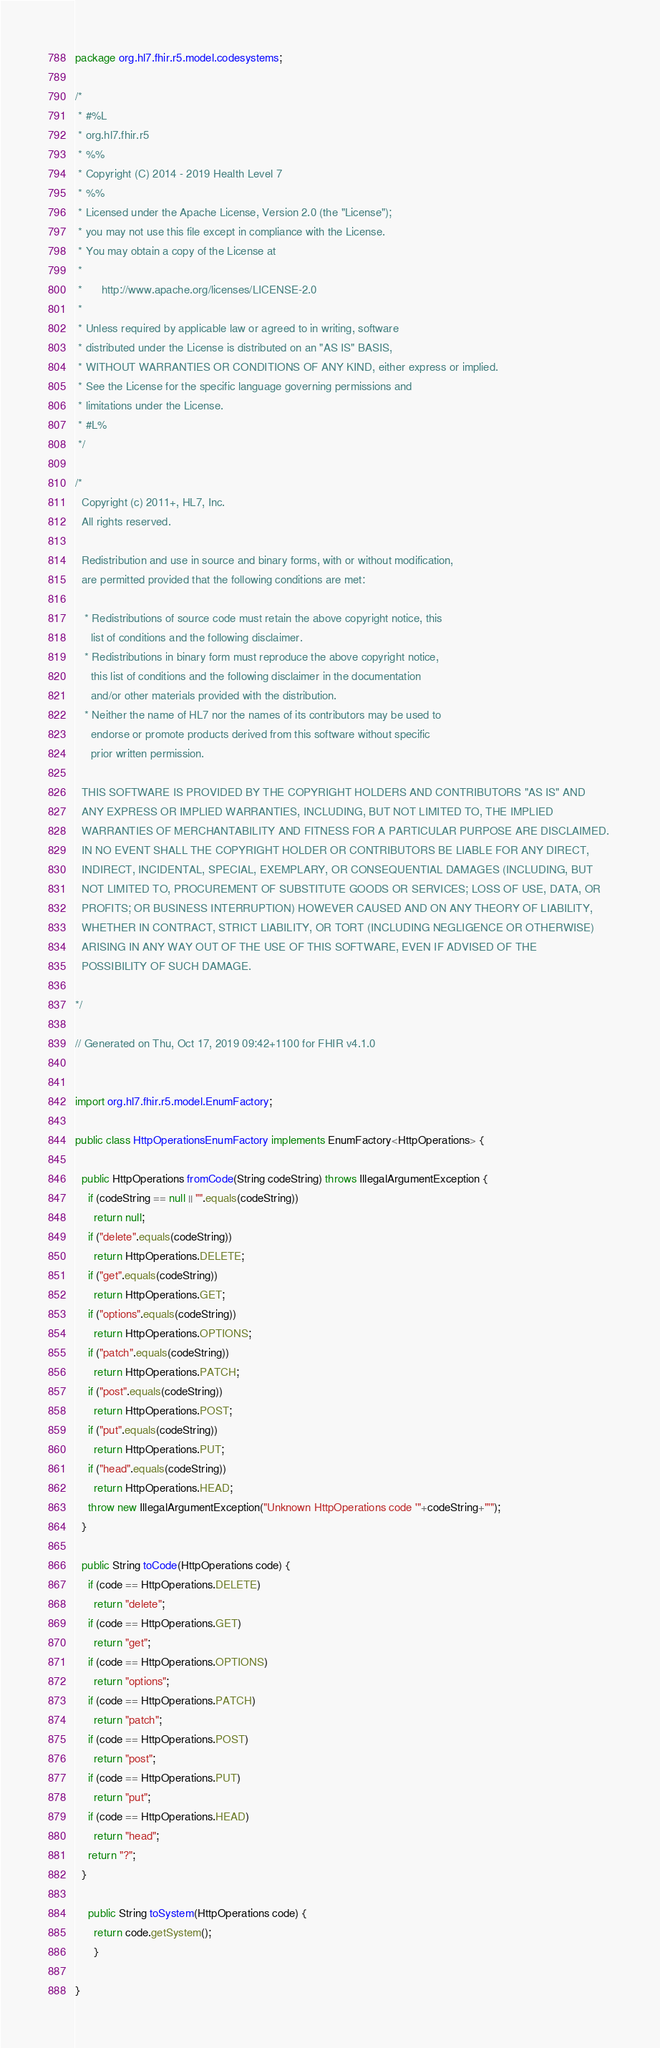<code> <loc_0><loc_0><loc_500><loc_500><_Java_>package org.hl7.fhir.r5.model.codesystems;

/*
 * #%L
 * org.hl7.fhir.r5
 * %%
 * Copyright (C) 2014 - 2019 Health Level 7
 * %%
 * Licensed under the Apache License, Version 2.0 (the "License");
 * you may not use this file except in compliance with the License.
 * You may obtain a copy of the License at
 * 
 *      http://www.apache.org/licenses/LICENSE-2.0
 * 
 * Unless required by applicable law or agreed to in writing, software
 * distributed under the License is distributed on an "AS IS" BASIS,
 * WITHOUT WARRANTIES OR CONDITIONS OF ANY KIND, either express or implied.
 * See the License for the specific language governing permissions and
 * limitations under the License.
 * #L%
 */

/*
  Copyright (c) 2011+, HL7, Inc.
  All rights reserved.
  
  Redistribution and use in source and binary forms, with or without modification, 
  are permitted provided that the following conditions are met:
  
   * Redistributions of source code must retain the above copyright notice, this 
     list of conditions and the following disclaimer.
   * Redistributions in binary form must reproduce the above copyright notice, 
     this list of conditions and the following disclaimer in the documentation 
     and/or other materials provided with the distribution.
   * Neither the name of HL7 nor the names of its contributors may be used to 
     endorse or promote products derived from this software without specific 
     prior written permission.
  
  THIS SOFTWARE IS PROVIDED BY THE COPYRIGHT HOLDERS AND CONTRIBUTORS "AS IS" AND 
  ANY EXPRESS OR IMPLIED WARRANTIES, INCLUDING, BUT NOT LIMITED TO, THE IMPLIED 
  WARRANTIES OF MERCHANTABILITY AND FITNESS FOR A PARTICULAR PURPOSE ARE DISCLAIMED. 
  IN NO EVENT SHALL THE COPYRIGHT HOLDER OR CONTRIBUTORS BE LIABLE FOR ANY DIRECT, 
  INDIRECT, INCIDENTAL, SPECIAL, EXEMPLARY, OR CONSEQUENTIAL DAMAGES (INCLUDING, BUT 
  NOT LIMITED TO, PROCUREMENT OF SUBSTITUTE GOODS OR SERVICES; LOSS OF USE, DATA, OR 
  PROFITS; OR BUSINESS INTERRUPTION) HOWEVER CAUSED AND ON ANY THEORY OF LIABILITY, 
  WHETHER IN CONTRACT, STRICT LIABILITY, OR TORT (INCLUDING NEGLIGENCE OR OTHERWISE) 
  ARISING IN ANY WAY OUT OF THE USE OF THIS SOFTWARE, EVEN IF ADVISED OF THE 
  POSSIBILITY OF SUCH DAMAGE.
  
*/

// Generated on Thu, Oct 17, 2019 09:42+1100 for FHIR v4.1.0


import org.hl7.fhir.r5.model.EnumFactory;

public class HttpOperationsEnumFactory implements EnumFactory<HttpOperations> {

  public HttpOperations fromCode(String codeString) throws IllegalArgumentException {
    if (codeString == null || "".equals(codeString))
      return null;
    if ("delete".equals(codeString))
      return HttpOperations.DELETE;
    if ("get".equals(codeString))
      return HttpOperations.GET;
    if ("options".equals(codeString))
      return HttpOperations.OPTIONS;
    if ("patch".equals(codeString))
      return HttpOperations.PATCH;
    if ("post".equals(codeString))
      return HttpOperations.POST;
    if ("put".equals(codeString))
      return HttpOperations.PUT;
    if ("head".equals(codeString))
      return HttpOperations.HEAD;
    throw new IllegalArgumentException("Unknown HttpOperations code '"+codeString+"'");
  }

  public String toCode(HttpOperations code) {
    if (code == HttpOperations.DELETE)
      return "delete";
    if (code == HttpOperations.GET)
      return "get";
    if (code == HttpOperations.OPTIONS)
      return "options";
    if (code == HttpOperations.PATCH)
      return "patch";
    if (code == HttpOperations.POST)
      return "post";
    if (code == HttpOperations.PUT)
      return "put";
    if (code == HttpOperations.HEAD)
      return "head";
    return "?";
  }

    public String toSystem(HttpOperations code) {
      return code.getSystem();
      }

}

</code> 